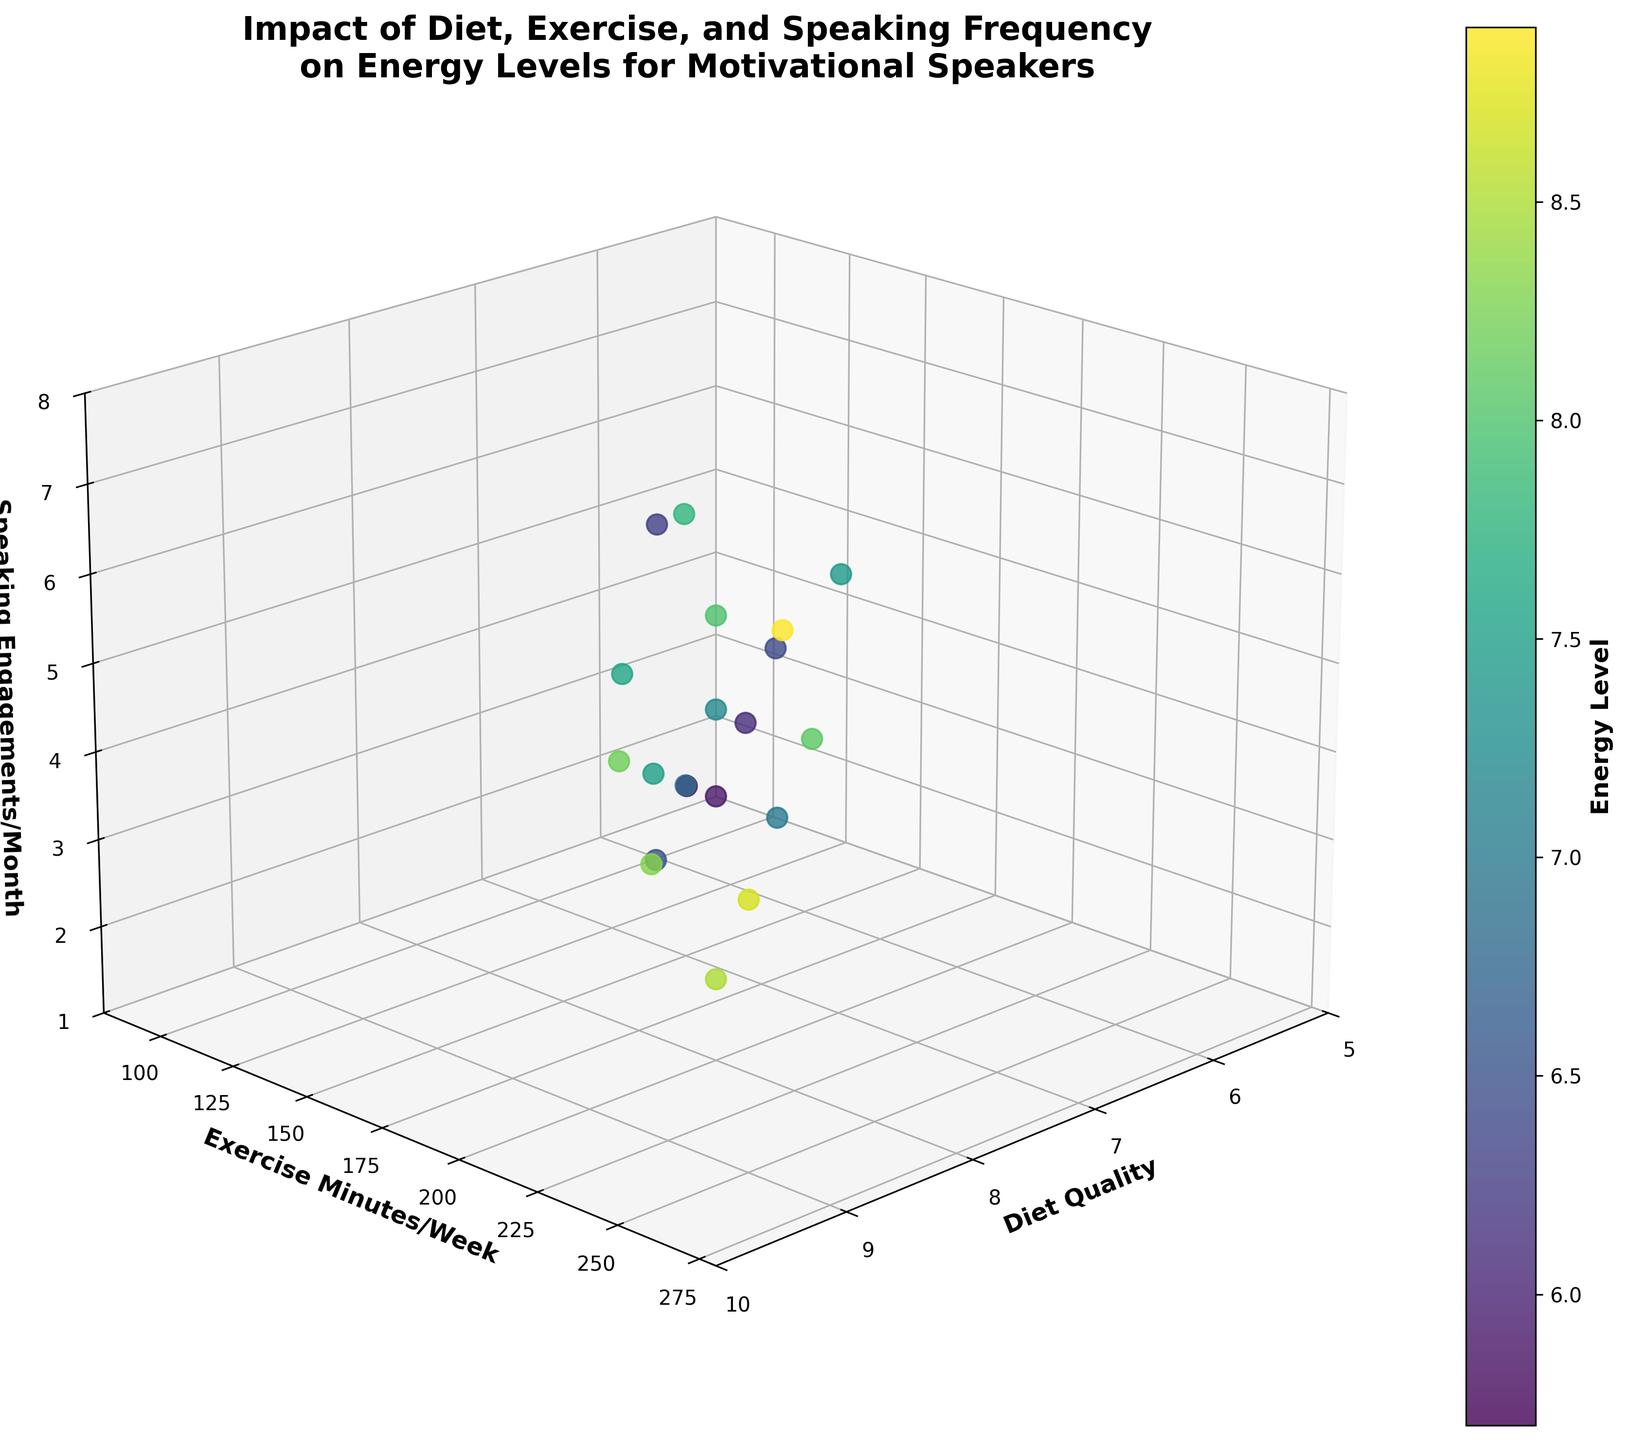How many axes and labels are there in the plot? The plot has three axes, and the labels are 'Diet Quality,' 'Exercise Minutes/Week,' and 'Speaking Engagements/Month.'
Answer: Three What is the title of the plot? The title of the plot is "Impact of Diet, Exercise, and Speaking Frequency on Energy Levels for Motivational Speakers."
Answer: "Impact of Diet, Exercise, and Speaking Frequency on Energy Levels for Motivational Speakers" What does the color of the points represent? The color of the points represents the 'Energy Level.'
Answer: 'Energy Level' What is the relationship between diet quality and energy level for points with over 200 exercise minutes per week? By examining the points with exercise minutes over 200, we see that higher diet quality correlates with higher energy levels. For instance, at diet quality 9, the energy levels are the highest.
Answer: Positive correlation Which factor, diet quality or speaking engagements per month, has a clearer visual correlation with energy levels? By examining the scatterplot, diet quality appears to have a clearer visual correlation with energy levels as higher diet qualities consistently show higher energy levels.
Answer: Diet quality What is the energy level indicated by the colorbar for the data point with diet quality 9, exercise minutes 260, and speaking engagements 7? Referring to the colorbar and the data point's position, the energy level is 8.9.
Answer: 8.9 Does having more speaking engagements per month generally result in higher energy levels? Based on visual interpretation, speakers with more speaking engagements per month do not necessarily have higher energy levels; energy levels are more correlated with diet quality and exercise minutes per week.
Answer: No What combination of factors leads to the highest energy level shown in the plot? The combination of diet quality 9, exercise minutes 260 per week, and 7 speaking engagements per month leads to the highest energy level of 8.9.
Answer: Diet quality 9, exercise minutes 260, 7 speaking engagements Comparing points with the same diet quality of 7, what is the effect of exercise minutes per week on energy levels? Comparing points with diet quality 7, those with higher exercise minutes per week generally have higher energy levels. For instance, 200 minutes of exercise correlates with an energy level of 7.4, while 140 minutes correlates with an energy level of 6.5.
Answer: Positive correlation What's the average energy level for data points with 8 diet quality? The energy levels for 8 diet quality are 7.5, 8.0, 7.8, and 8.1. The sum is 31.4, and there are 4 points, thus the average is 31.4/4 = 7.85.
Answer: 7.85 